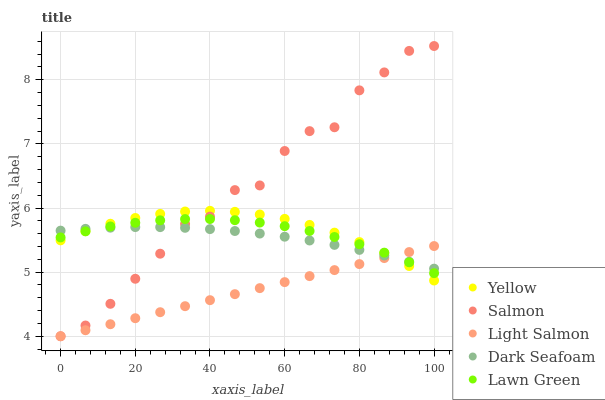Does Light Salmon have the minimum area under the curve?
Answer yes or no. Yes. Does Salmon have the maximum area under the curve?
Answer yes or no. Yes. Does Salmon have the minimum area under the curve?
Answer yes or no. No. Does Light Salmon have the maximum area under the curve?
Answer yes or no. No. Is Light Salmon the smoothest?
Answer yes or no. Yes. Is Salmon the roughest?
Answer yes or no. Yes. Is Salmon the smoothest?
Answer yes or no. No. Is Light Salmon the roughest?
Answer yes or no. No. Does Light Salmon have the lowest value?
Answer yes or no. Yes. Does Dark Seafoam have the lowest value?
Answer yes or no. No. Does Salmon have the highest value?
Answer yes or no. Yes. Does Light Salmon have the highest value?
Answer yes or no. No. Does Light Salmon intersect Yellow?
Answer yes or no. Yes. Is Light Salmon less than Yellow?
Answer yes or no. No. Is Light Salmon greater than Yellow?
Answer yes or no. No. 